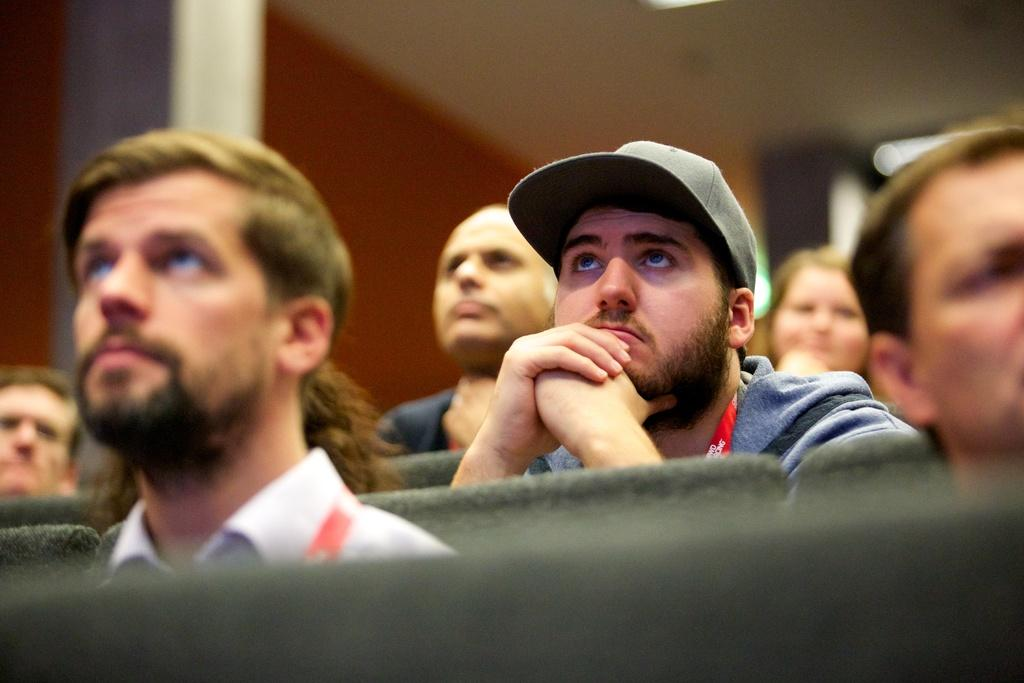What are the people in the image doing? The people in the image are sitting on chairs. Can you describe the clothing of one of the individuals? One man is wearing a cap. How would you describe the background of the image? The background of the image is blurred. How many dimes can be seen on the floor in the image? There are no dimes visible on the floor in the image. What color is the angle in the image? There is no angle present in the image, and therefore no color can be assigned to it. 